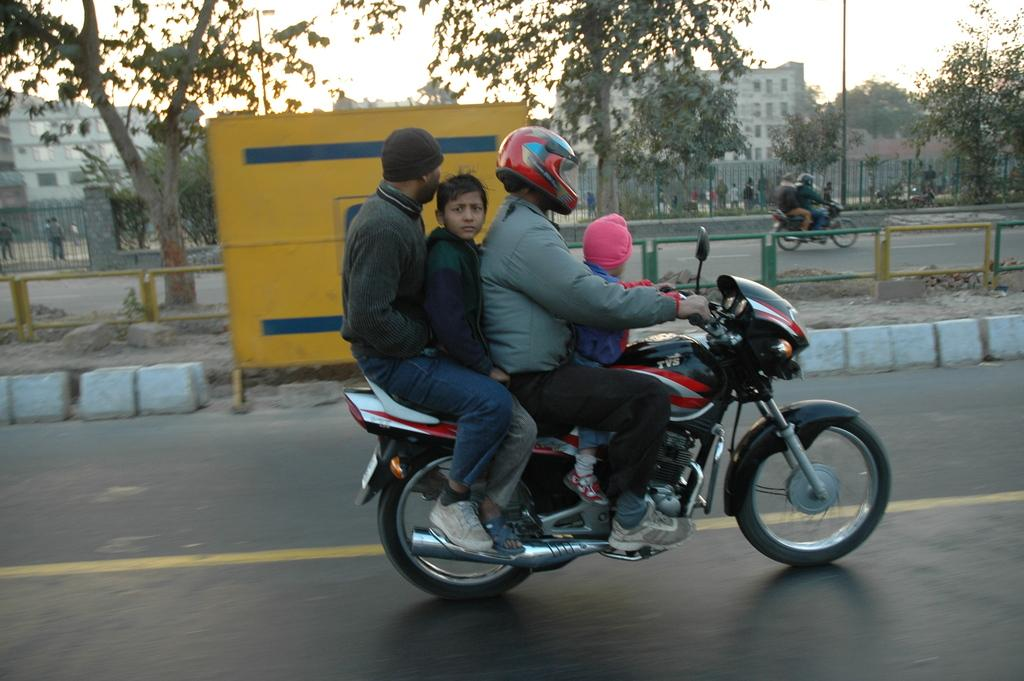How many people are on the bike in the image? There are four persons on the bike in the image. What type of location is depicted in the image? This is a road. What natural elements can be seen in the image? There are trees visible in the image. What type of structure is present in the image? There is a building in the image. What man-made object can be seen in the image? There is a pole in the image. What type of summer clothing can be seen on the persons in the image? The provided facts do not mention any clothing or the season, so we cannot determine the type of summer clothing in the image. 